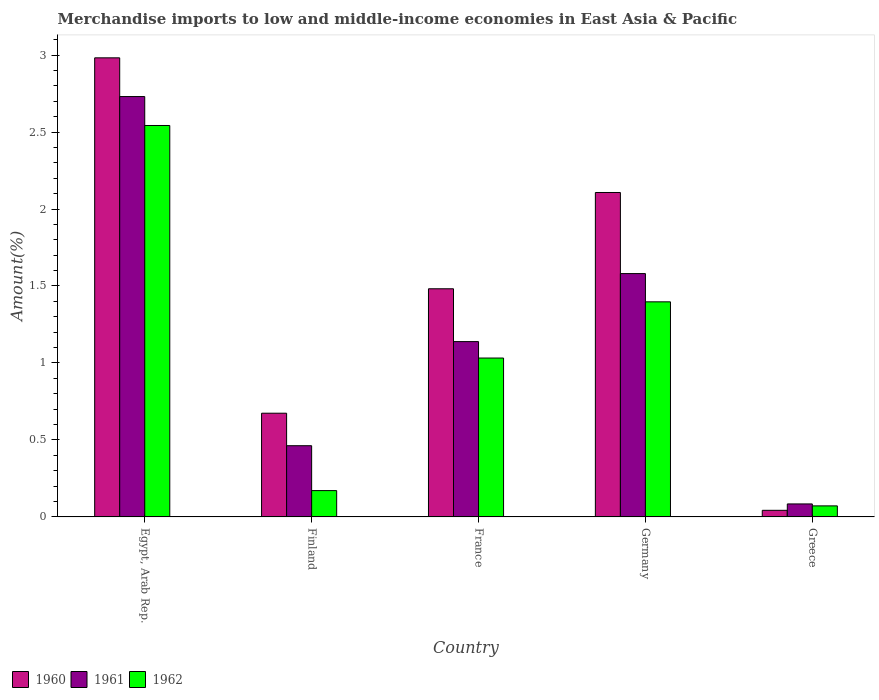How many groups of bars are there?
Make the answer very short. 5. Are the number of bars on each tick of the X-axis equal?
Your answer should be very brief. Yes. How many bars are there on the 2nd tick from the left?
Your answer should be compact. 3. What is the label of the 1st group of bars from the left?
Provide a short and direct response. Egypt, Arab Rep. In how many cases, is the number of bars for a given country not equal to the number of legend labels?
Offer a very short reply. 0. What is the percentage of amount earned from merchandise imports in 1960 in Egypt, Arab Rep.?
Your response must be concise. 2.98. Across all countries, what is the maximum percentage of amount earned from merchandise imports in 1960?
Make the answer very short. 2.98. Across all countries, what is the minimum percentage of amount earned from merchandise imports in 1960?
Your answer should be very brief. 0.04. In which country was the percentage of amount earned from merchandise imports in 1962 maximum?
Provide a succinct answer. Egypt, Arab Rep. What is the total percentage of amount earned from merchandise imports in 1961 in the graph?
Make the answer very short. 6. What is the difference between the percentage of amount earned from merchandise imports in 1962 in Egypt, Arab Rep. and that in France?
Offer a terse response. 1.51. What is the difference between the percentage of amount earned from merchandise imports in 1961 in Greece and the percentage of amount earned from merchandise imports in 1962 in Finland?
Your answer should be very brief. -0.09. What is the average percentage of amount earned from merchandise imports in 1961 per country?
Keep it short and to the point. 1.2. What is the difference between the percentage of amount earned from merchandise imports of/in 1960 and percentage of amount earned from merchandise imports of/in 1962 in Finland?
Your answer should be compact. 0.5. In how many countries, is the percentage of amount earned from merchandise imports in 1961 greater than 1 %?
Keep it short and to the point. 3. What is the ratio of the percentage of amount earned from merchandise imports in 1960 in Egypt, Arab Rep. to that in Greece?
Keep it short and to the point. 69.41. Is the percentage of amount earned from merchandise imports in 1960 in Germany less than that in Greece?
Provide a short and direct response. No. Is the difference between the percentage of amount earned from merchandise imports in 1960 in Finland and Greece greater than the difference between the percentage of amount earned from merchandise imports in 1962 in Finland and Greece?
Provide a short and direct response. Yes. What is the difference between the highest and the second highest percentage of amount earned from merchandise imports in 1962?
Give a very brief answer. -1.15. What is the difference between the highest and the lowest percentage of amount earned from merchandise imports in 1960?
Give a very brief answer. 2.94. In how many countries, is the percentage of amount earned from merchandise imports in 1961 greater than the average percentage of amount earned from merchandise imports in 1961 taken over all countries?
Provide a short and direct response. 2. Is the sum of the percentage of amount earned from merchandise imports in 1961 in Egypt, Arab Rep. and Greece greater than the maximum percentage of amount earned from merchandise imports in 1962 across all countries?
Provide a short and direct response. Yes. What does the 2nd bar from the left in Egypt, Arab Rep. represents?
Provide a succinct answer. 1961. What does the 2nd bar from the right in France represents?
Your response must be concise. 1961. Is it the case that in every country, the sum of the percentage of amount earned from merchandise imports in 1962 and percentage of amount earned from merchandise imports in 1961 is greater than the percentage of amount earned from merchandise imports in 1960?
Your answer should be compact. No. How many bars are there?
Provide a succinct answer. 15. Are all the bars in the graph horizontal?
Your response must be concise. No. How many countries are there in the graph?
Offer a very short reply. 5. What is the difference between two consecutive major ticks on the Y-axis?
Give a very brief answer. 0.5. Are the values on the major ticks of Y-axis written in scientific E-notation?
Provide a short and direct response. No. Does the graph contain grids?
Provide a succinct answer. No. Where does the legend appear in the graph?
Keep it short and to the point. Bottom left. How many legend labels are there?
Your response must be concise. 3. What is the title of the graph?
Keep it short and to the point. Merchandise imports to low and middle-income economies in East Asia & Pacific. What is the label or title of the Y-axis?
Offer a terse response. Amount(%). What is the Amount(%) in 1960 in Egypt, Arab Rep.?
Make the answer very short. 2.98. What is the Amount(%) in 1961 in Egypt, Arab Rep.?
Provide a succinct answer. 2.73. What is the Amount(%) of 1962 in Egypt, Arab Rep.?
Your answer should be compact. 2.54. What is the Amount(%) in 1960 in Finland?
Keep it short and to the point. 0.67. What is the Amount(%) of 1961 in Finland?
Your answer should be very brief. 0.46. What is the Amount(%) in 1962 in Finland?
Give a very brief answer. 0.17. What is the Amount(%) in 1960 in France?
Keep it short and to the point. 1.48. What is the Amount(%) in 1961 in France?
Offer a terse response. 1.14. What is the Amount(%) in 1962 in France?
Offer a very short reply. 1.03. What is the Amount(%) in 1960 in Germany?
Keep it short and to the point. 2.11. What is the Amount(%) in 1961 in Germany?
Give a very brief answer. 1.58. What is the Amount(%) in 1962 in Germany?
Your answer should be very brief. 1.4. What is the Amount(%) of 1960 in Greece?
Offer a very short reply. 0.04. What is the Amount(%) in 1961 in Greece?
Your answer should be very brief. 0.08. What is the Amount(%) in 1962 in Greece?
Provide a succinct answer. 0.07. Across all countries, what is the maximum Amount(%) of 1960?
Offer a terse response. 2.98. Across all countries, what is the maximum Amount(%) in 1961?
Your answer should be very brief. 2.73. Across all countries, what is the maximum Amount(%) in 1962?
Make the answer very short. 2.54. Across all countries, what is the minimum Amount(%) of 1960?
Offer a very short reply. 0.04. Across all countries, what is the minimum Amount(%) in 1961?
Offer a terse response. 0.08. Across all countries, what is the minimum Amount(%) of 1962?
Your answer should be very brief. 0.07. What is the total Amount(%) in 1960 in the graph?
Your answer should be compact. 7.29. What is the total Amount(%) of 1961 in the graph?
Your answer should be very brief. 6. What is the total Amount(%) of 1962 in the graph?
Ensure brevity in your answer.  5.21. What is the difference between the Amount(%) in 1960 in Egypt, Arab Rep. and that in Finland?
Make the answer very short. 2.31. What is the difference between the Amount(%) in 1961 in Egypt, Arab Rep. and that in Finland?
Your response must be concise. 2.27. What is the difference between the Amount(%) of 1962 in Egypt, Arab Rep. and that in Finland?
Provide a succinct answer. 2.37. What is the difference between the Amount(%) in 1960 in Egypt, Arab Rep. and that in France?
Ensure brevity in your answer.  1.5. What is the difference between the Amount(%) of 1961 in Egypt, Arab Rep. and that in France?
Your response must be concise. 1.59. What is the difference between the Amount(%) in 1962 in Egypt, Arab Rep. and that in France?
Your answer should be very brief. 1.51. What is the difference between the Amount(%) of 1960 in Egypt, Arab Rep. and that in Germany?
Provide a succinct answer. 0.87. What is the difference between the Amount(%) of 1961 in Egypt, Arab Rep. and that in Germany?
Offer a terse response. 1.15. What is the difference between the Amount(%) in 1962 in Egypt, Arab Rep. and that in Germany?
Make the answer very short. 1.15. What is the difference between the Amount(%) of 1960 in Egypt, Arab Rep. and that in Greece?
Provide a succinct answer. 2.94. What is the difference between the Amount(%) in 1961 in Egypt, Arab Rep. and that in Greece?
Your answer should be very brief. 2.65. What is the difference between the Amount(%) in 1962 in Egypt, Arab Rep. and that in Greece?
Offer a very short reply. 2.47. What is the difference between the Amount(%) of 1960 in Finland and that in France?
Provide a short and direct response. -0.81. What is the difference between the Amount(%) in 1961 in Finland and that in France?
Give a very brief answer. -0.68. What is the difference between the Amount(%) of 1962 in Finland and that in France?
Ensure brevity in your answer.  -0.86. What is the difference between the Amount(%) of 1960 in Finland and that in Germany?
Your answer should be very brief. -1.43. What is the difference between the Amount(%) in 1961 in Finland and that in Germany?
Make the answer very short. -1.12. What is the difference between the Amount(%) of 1962 in Finland and that in Germany?
Provide a succinct answer. -1.23. What is the difference between the Amount(%) of 1960 in Finland and that in Greece?
Keep it short and to the point. 0.63. What is the difference between the Amount(%) of 1961 in Finland and that in Greece?
Make the answer very short. 0.38. What is the difference between the Amount(%) of 1962 in Finland and that in Greece?
Provide a succinct answer. 0.1. What is the difference between the Amount(%) in 1960 in France and that in Germany?
Provide a succinct answer. -0.63. What is the difference between the Amount(%) of 1961 in France and that in Germany?
Offer a very short reply. -0.44. What is the difference between the Amount(%) of 1962 in France and that in Germany?
Your answer should be compact. -0.36. What is the difference between the Amount(%) in 1960 in France and that in Greece?
Ensure brevity in your answer.  1.44. What is the difference between the Amount(%) in 1961 in France and that in Greece?
Make the answer very short. 1.05. What is the difference between the Amount(%) in 1962 in France and that in Greece?
Offer a very short reply. 0.96. What is the difference between the Amount(%) of 1960 in Germany and that in Greece?
Your response must be concise. 2.06. What is the difference between the Amount(%) in 1961 in Germany and that in Greece?
Ensure brevity in your answer.  1.5. What is the difference between the Amount(%) of 1962 in Germany and that in Greece?
Provide a short and direct response. 1.33. What is the difference between the Amount(%) in 1960 in Egypt, Arab Rep. and the Amount(%) in 1961 in Finland?
Your response must be concise. 2.52. What is the difference between the Amount(%) of 1960 in Egypt, Arab Rep. and the Amount(%) of 1962 in Finland?
Make the answer very short. 2.81. What is the difference between the Amount(%) of 1961 in Egypt, Arab Rep. and the Amount(%) of 1962 in Finland?
Your response must be concise. 2.56. What is the difference between the Amount(%) of 1960 in Egypt, Arab Rep. and the Amount(%) of 1961 in France?
Give a very brief answer. 1.84. What is the difference between the Amount(%) of 1960 in Egypt, Arab Rep. and the Amount(%) of 1962 in France?
Provide a short and direct response. 1.95. What is the difference between the Amount(%) of 1961 in Egypt, Arab Rep. and the Amount(%) of 1962 in France?
Ensure brevity in your answer.  1.7. What is the difference between the Amount(%) in 1960 in Egypt, Arab Rep. and the Amount(%) in 1961 in Germany?
Give a very brief answer. 1.4. What is the difference between the Amount(%) of 1960 in Egypt, Arab Rep. and the Amount(%) of 1962 in Germany?
Provide a succinct answer. 1.58. What is the difference between the Amount(%) of 1961 in Egypt, Arab Rep. and the Amount(%) of 1962 in Germany?
Keep it short and to the point. 1.33. What is the difference between the Amount(%) of 1960 in Egypt, Arab Rep. and the Amount(%) of 1961 in Greece?
Provide a succinct answer. 2.9. What is the difference between the Amount(%) in 1960 in Egypt, Arab Rep. and the Amount(%) in 1962 in Greece?
Keep it short and to the point. 2.91. What is the difference between the Amount(%) of 1961 in Egypt, Arab Rep. and the Amount(%) of 1962 in Greece?
Offer a very short reply. 2.66. What is the difference between the Amount(%) of 1960 in Finland and the Amount(%) of 1961 in France?
Offer a very short reply. -0.47. What is the difference between the Amount(%) of 1960 in Finland and the Amount(%) of 1962 in France?
Offer a very short reply. -0.36. What is the difference between the Amount(%) of 1961 in Finland and the Amount(%) of 1962 in France?
Provide a succinct answer. -0.57. What is the difference between the Amount(%) in 1960 in Finland and the Amount(%) in 1961 in Germany?
Provide a short and direct response. -0.91. What is the difference between the Amount(%) of 1960 in Finland and the Amount(%) of 1962 in Germany?
Your answer should be compact. -0.72. What is the difference between the Amount(%) in 1961 in Finland and the Amount(%) in 1962 in Germany?
Provide a short and direct response. -0.93. What is the difference between the Amount(%) of 1960 in Finland and the Amount(%) of 1961 in Greece?
Keep it short and to the point. 0.59. What is the difference between the Amount(%) in 1960 in Finland and the Amount(%) in 1962 in Greece?
Give a very brief answer. 0.6. What is the difference between the Amount(%) in 1961 in Finland and the Amount(%) in 1962 in Greece?
Ensure brevity in your answer.  0.39. What is the difference between the Amount(%) in 1960 in France and the Amount(%) in 1961 in Germany?
Keep it short and to the point. -0.1. What is the difference between the Amount(%) in 1960 in France and the Amount(%) in 1962 in Germany?
Your answer should be very brief. 0.08. What is the difference between the Amount(%) of 1961 in France and the Amount(%) of 1962 in Germany?
Your response must be concise. -0.26. What is the difference between the Amount(%) of 1960 in France and the Amount(%) of 1961 in Greece?
Offer a terse response. 1.4. What is the difference between the Amount(%) in 1960 in France and the Amount(%) in 1962 in Greece?
Provide a short and direct response. 1.41. What is the difference between the Amount(%) in 1961 in France and the Amount(%) in 1962 in Greece?
Offer a very short reply. 1.07. What is the difference between the Amount(%) in 1960 in Germany and the Amount(%) in 1961 in Greece?
Give a very brief answer. 2.02. What is the difference between the Amount(%) of 1960 in Germany and the Amount(%) of 1962 in Greece?
Give a very brief answer. 2.04. What is the difference between the Amount(%) of 1961 in Germany and the Amount(%) of 1962 in Greece?
Provide a succinct answer. 1.51. What is the average Amount(%) in 1960 per country?
Provide a short and direct response. 1.46. What is the average Amount(%) in 1961 per country?
Provide a short and direct response. 1.2. What is the average Amount(%) of 1962 per country?
Make the answer very short. 1.04. What is the difference between the Amount(%) of 1960 and Amount(%) of 1961 in Egypt, Arab Rep.?
Offer a very short reply. 0.25. What is the difference between the Amount(%) of 1960 and Amount(%) of 1962 in Egypt, Arab Rep.?
Offer a terse response. 0.44. What is the difference between the Amount(%) in 1961 and Amount(%) in 1962 in Egypt, Arab Rep.?
Provide a short and direct response. 0.19. What is the difference between the Amount(%) in 1960 and Amount(%) in 1961 in Finland?
Provide a succinct answer. 0.21. What is the difference between the Amount(%) of 1960 and Amount(%) of 1962 in Finland?
Keep it short and to the point. 0.5. What is the difference between the Amount(%) in 1961 and Amount(%) in 1962 in Finland?
Provide a succinct answer. 0.29. What is the difference between the Amount(%) of 1960 and Amount(%) of 1961 in France?
Offer a terse response. 0.34. What is the difference between the Amount(%) in 1960 and Amount(%) in 1962 in France?
Your response must be concise. 0.45. What is the difference between the Amount(%) in 1961 and Amount(%) in 1962 in France?
Ensure brevity in your answer.  0.11. What is the difference between the Amount(%) of 1960 and Amount(%) of 1961 in Germany?
Your response must be concise. 0.53. What is the difference between the Amount(%) of 1960 and Amount(%) of 1962 in Germany?
Make the answer very short. 0.71. What is the difference between the Amount(%) of 1961 and Amount(%) of 1962 in Germany?
Your answer should be compact. 0.18. What is the difference between the Amount(%) in 1960 and Amount(%) in 1961 in Greece?
Your answer should be very brief. -0.04. What is the difference between the Amount(%) in 1960 and Amount(%) in 1962 in Greece?
Provide a short and direct response. -0.03. What is the difference between the Amount(%) in 1961 and Amount(%) in 1962 in Greece?
Provide a short and direct response. 0.01. What is the ratio of the Amount(%) in 1960 in Egypt, Arab Rep. to that in Finland?
Make the answer very short. 4.43. What is the ratio of the Amount(%) in 1961 in Egypt, Arab Rep. to that in Finland?
Keep it short and to the point. 5.9. What is the ratio of the Amount(%) in 1962 in Egypt, Arab Rep. to that in Finland?
Ensure brevity in your answer.  14.87. What is the ratio of the Amount(%) in 1960 in Egypt, Arab Rep. to that in France?
Offer a very short reply. 2.01. What is the ratio of the Amount(%) of 1961 in Egypt, Arab Rep. to that in France?
Give a very brief answer. 2.4. What is the ratio of the Amount(%) of 1962 in Egypt, Arab Rep. to that in France?
Offer a very short reply. 2.46. What is the ratio of the Amount(%) of 1960 in Egypt, Arab Rep. to that in Germany?
Ensure brevity in your answer.  1.42. What is the ratio of the Amount(%) of 1961 in Egypt, Arab Rep. to that in Germany?
Offer a terse response. 1.73. What is the ratio of the Amount(%) in 1962 in Egypt, Arab Rep. to that in Germany?
Your answer should be compact. 1.82. What is the ratio of the Amount(%) in 1960 in Egypt, Arab Rep. to that in Greece?
Offer a terse response. 69.41. What is the ratio of the Amount(%) of 1961 in Egypt, Arab Rep. to that in Greece?
Offer a very short reply. 32.33. What is the ratio of the Amount(%) of 1962 in Egypt, Arab Rep. to that in Greece?
Provide a short and direct response. 35.41. What is the ratio of the Amount(%) of 1960 in Finland to that in France?
Your answer should be very brief. 0.45. What is the ratio of the Amount(%) in 1961 in Finland to that in France?
Offer a terse response. 0.41. What is the ratio of the Amount(%) in 1962 in Finland to that in France?
Offer a terse response. 0.17. What is the ratio of the Amount(%) of 1960 in Finland to that in Germany?
Your answer should be compact. 0.32. What is the ratio of the Amount(%) of 1961 in Finland to that in Germany?
Keep it short and to the point. 0.29. What is the ratio of the Amount(%) of 1962 in Finland to that in Germany?
Give a very brief answer. 0.12. What is the ratio of the Amount(%) of 1960 in Finland to that in Greece?
Offer a terse response. 15.68. What is the ratio of the Amount(%) of 1961 in Finland to that in Greece?
Offer a very short reply. 5.48. What is the ratio of the Amount(%) of 1962 in Finland to that in Greece?
Ensure brevity in your answer.  2.38. What is the ratio of the Amount(%) of 1960 in France to that in Germany?
Keep it short and to the point. 0.7. What is the ratio of the Amount(%) in 1961 in France to that in Germany?
Your answer should be compact. 0.72. What is the ratio of the Amount(%) in 1962 in France to that in Germany?
Your answer should be very brief. 0.74. What is the ratio of the Amount(%) in 1960 in France to that in Greece?
Provide a succinct answer. 34.49. What is the ratio of the Amount(%) of 1961 in France to that in Greece?
Offer a terse response. 13.48. What is the ratio of the Amount(%) of 1962 in France to that in Greece?
Give a very brief answer. 14.37. What is the ratio of the Amount(%) in 1960 in Germany to that in Greece?
Provide a short and direct response. 49.05. What is the ratio of the Amount(%) of 1961 in Germany to that in Greece?
Your response must be concise. 18.72. What is the ratio of the Amount(%) of 1962 in Germany to that in Greece?
Provide a succinct answer. 19.46. What is the difference between the highest and the second highest Amount(%) of 1960?
Offer a terse response. 0.87. What is the difference between the highest and the second highest Amount(%) of 1961?
Keep it short and to the point. 1.15. What is the difference between the highest and the second highest Amount(%) of 1962?
Your response must be concise. 1.15. What is the difference between the highest and the lowest Amount(%) in 1960?
Make the answer very short. 2.94. What is the difference between the highest and the lowest Amount(%) in 1961?
Provide a succinct answer. 2.65. What is the difference between the highest and the lowest Amount(%) of 1962?
Your answer should be compact. 2.47. 